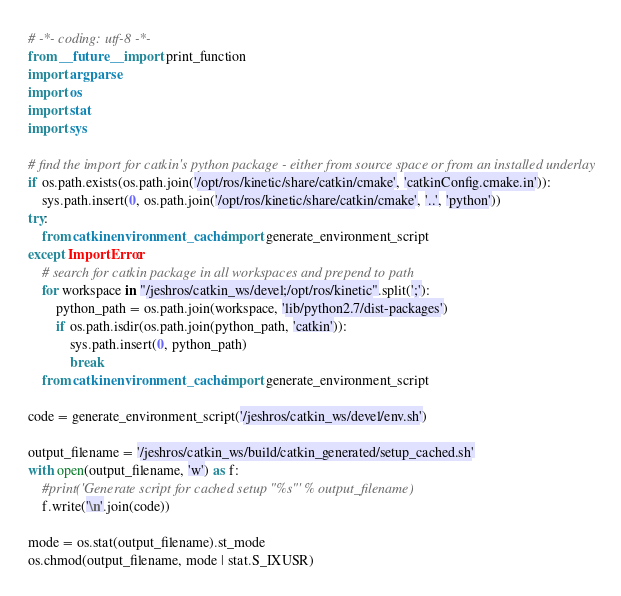Convert code to text. <code><loc_0><loc_0><loc_500><loc_500><_Python_># -*- coding: utf-8 -*-
from __future__ import print_function
import argparse
import os
import stat
import sys

# find the import for catkin's python package - either from source space or from an installed underlay
if os.path.exists(os.path.join('/opt/ros/kinetic/share/catkin/cmake', 'catkinConfig.cmake.in')):
    sys.path.insert(0, os.path.join('/opt/ros/kinetic/share/catkin/cmake', '..', 'python'))
try:
    from catkin.environment_cache import generate_environment_script
except ImportError:
    # search for catkin package in all workspaces and prepend to path
    for workspace in "/jeshros/catkin_ws/devel;/opt/ros/kinetic".split(';'):
        python_path = os.path.join(workspace, 'lib/python2.7/dist-packages')
        if os.path.isdir(os.path.join(python_path, 'catkin')):
            sys.path.insert(0, python_path)
            break
    from catkin.environment_cache import generate_environment_script

code = generate_environment_script('/jeshros/catkin_ws/devel/env.sh')

output_filename = '/jeshros/catkin_ws/build/catkin_generated/setup_cached.sh'
with open(output_filename, 'w') as f:
    #print('Generate script for cached setup "%s"' % output_filename)
    f.write('\n'.join(code))

mode = os.stat(output_filename).st_mode
os.chmod(output_filename, mode | stat.S_IXUSR)
</code> 